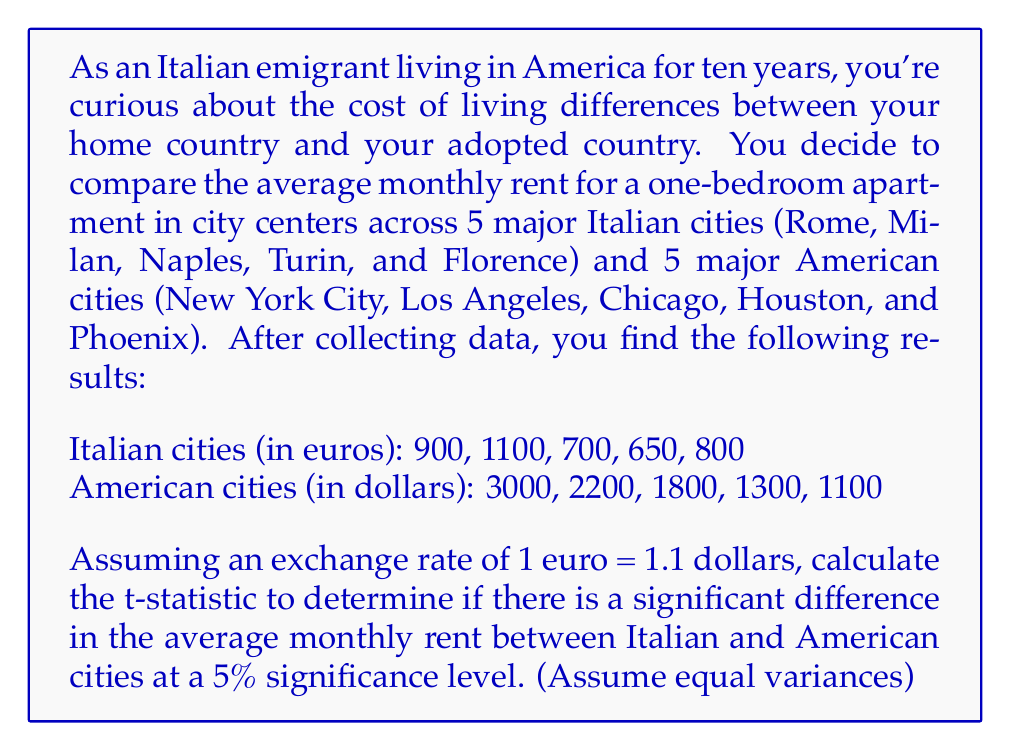Show me your answer to this math problem. To solve this problem, we'll follow these steps:

1) Convert Italian rents to dollars:
   $900 * 1.1 = 990, 1100 * 1.1 = 1210, 700 * 1.1 = 770, 650 * 1.1 = 715, 800 * 1.1 = 880$

2) Calculate means:
   Italian mean ($\bar{X}_1$): $\frac{990 + 1210 + 770 + 715 + 880}{5} = 913$
   American mean ($\bar{X}_2$): $\frac{3000 + 2200 + 1800 + 1300 + 1100}{5} = 1880$

3) Calculate sample variances:
   Italian variance ($s_1^2$):
   $$s_1^2 = \frac{\sum(X_1 - \bar{X}_1)^2}{n_1 - 1} = \frac{(990-913)^2 + ... + (880-913)^2}{4} = 41,665$$
   
   American variance ($s_2^2$):
   $$s_2^2 = \frac{\sum(X_2 - \bar{X}_2)^2}{n_2 - 1} = \frac{(3000-1880)^2 + ... + (1100-1880)^2}{4} = 620,700$$

4) Calculate pooled standard deviation:
   $$s_p = \sqrt{\frac{(n_1-1)s_1^2 + (n_2-1)s_2^2}{n_1+n_2-2}} = \sqrt{\frac{4(41,665) + 4(620,700)}{8}} = 559.78$$

5) Calculate t-statistic:
   $$t = \frac{\bar{X}_1 - \bar{X}_2}{s_p\sqrt{\frac{2}{n}}} = \frac{913 - 1880}{559.78\sqrt{\frac{2}{5}}} = -3.07$$

6) Degrees of freedom: $df = n_1 + n_2 - 2 = 5 + 5 - 2 = 8$

7) The critical t-value for a two-tailed test at 5% significance level with 8 df is approximately ±2.306.

Since |-3.07| > 2.306, we reject the null hypothesis.
Answer: The calculated t-statistic is -3.07. Since this value is outside the critical region (|-3.07| > 2.306), we conclude that there is a significant difference in the average monthly rent between major Italian and American cities at the 5% significance level. 